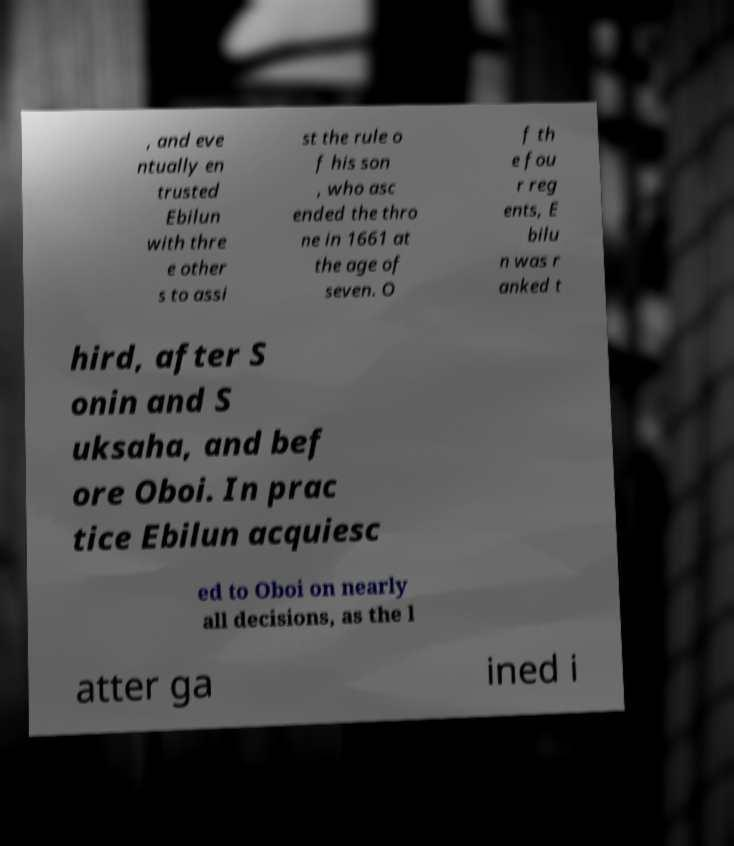For documentation purposes, I need the text within this image transcribed. Could you provide that? , and eve ntually en trusted Ebilun with thre e other s to assi st the rule o f his son , who asc ended the thro ne in 1661 at the age of seven. O f th e fou r reg ents, E bilu n was r anked t hird, after S onin and S uksaha, and bef ore Oboi. In prac tice Ebilun acquiesc ed to Oboi on nearly all decisions, as the l atter ga ined i 